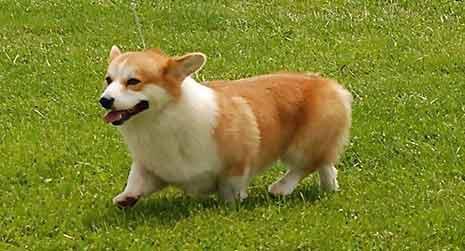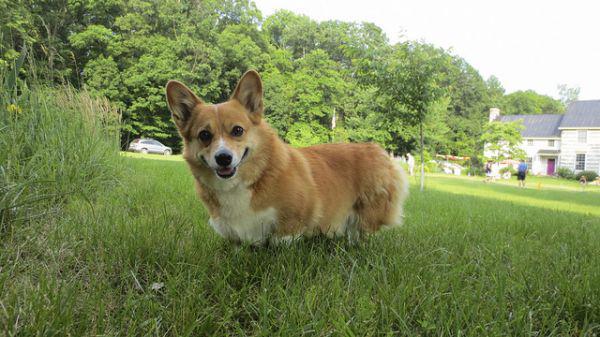The first image is the image on the left, the second image is the image on the right. Considering the images on both sides, is "In the left image there is a dog with its front paw up." valid? Answer yes or no. Yes. 